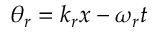<formula> <loc_0><loc_0><loc_500><loc_500>\theta _ { r } = k _ { r } x - \omega _ { r } t</formula> 